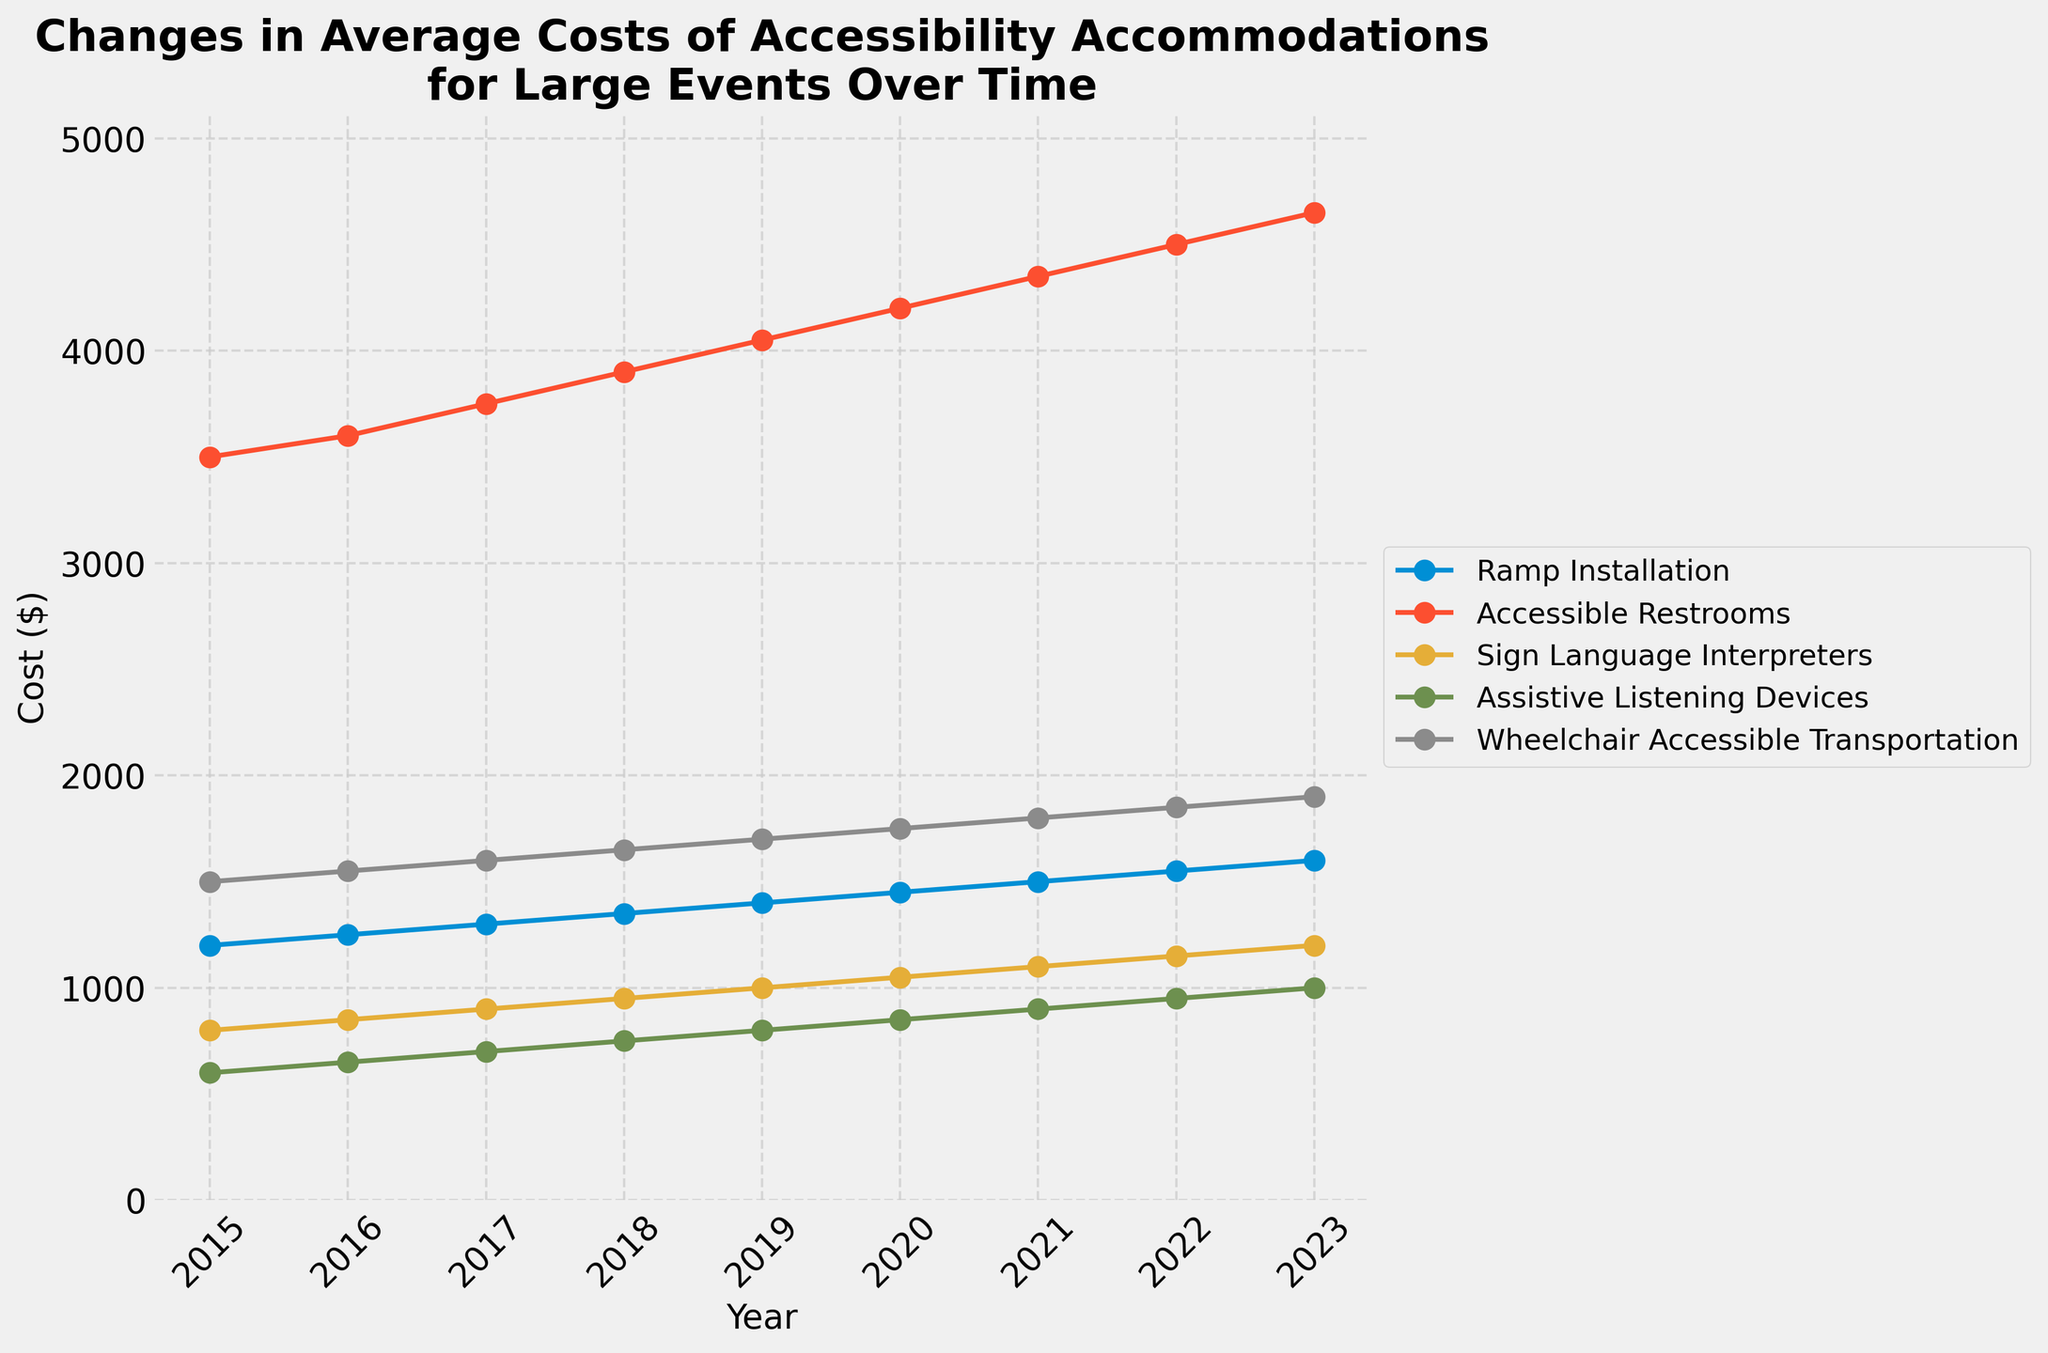What was the cost of Ramp Installation in 2015 and 2023? The cost of Ramp Installation in 2015 is shown at the leftmost point on the gold line, marking the start year, and the cost in 2023 is shown at the rightmost point on the same line. According to the legend, the gold line represents Ramp Installation costs.
Answer: 2015: $1200, 2023: $1600 Which accessibility accommodation had the highest cost in 2023? By looking at the 2023 values for all lines, the highest point corresponds to the Accessible Restrooms (blue line) at a cost of $4650.
Answer: Accessible Restrooms Between which two consecutive years did Assistive Listening Devices see the highest cost increase? Checking the height differences of the Assistive Listening Devices (orange line) between each consecutive year, the largest vertical increase is between 2016 and 2017 where it goes from $650 to $700.
Answer: 2016 and 2017 How much did the cost of Sign Language Interpreters increase from 2015 to 2020? Starting at 2015, look at the green line value at the beginning year ($800) and then the value at 2020 ($1050). The increase is $1050 - $800.
Answer: $250 What is the average cost of Wheelchair Accessible Transportation from 2015 to 2023? Sum up Wheelchair Accessible Transportation costs for every year between 2015 and 2023: (1500 + 1550 + 1600 + 1650 + 1700 + 1750 + 1800 + 1850 + 1900), and then divide by the number of years (9). Average is (14500 / 9).
Answer: $1600 Which year saw the highest jump in the cost of Accessible Restrooms and what was the amount? Following the blue line and noting values, the highest jump is between 2016 ($3600) and 2017 ($3750). The increase amount is $3750 - $3600.
Answer: 2017, $150 By how much did the cost of Sign Language Interpreters change from 2018 to 2022? Observing the green line, the cost in 2018 was $950, and in 2022 it was $1150. The change is $1150 - $950.
Answer: $200 Which accommodation's cost had the smallest absolute increase from 2015 to 2023? Calculate the changes for each accommodation from 2015 to 2023 by subtracting the 2015 value from the 2023 value and compare. The smallest change is for Assistive Listening Devices, with an increase from $600 to $1000.
Answer: Assistive Listening Devices 